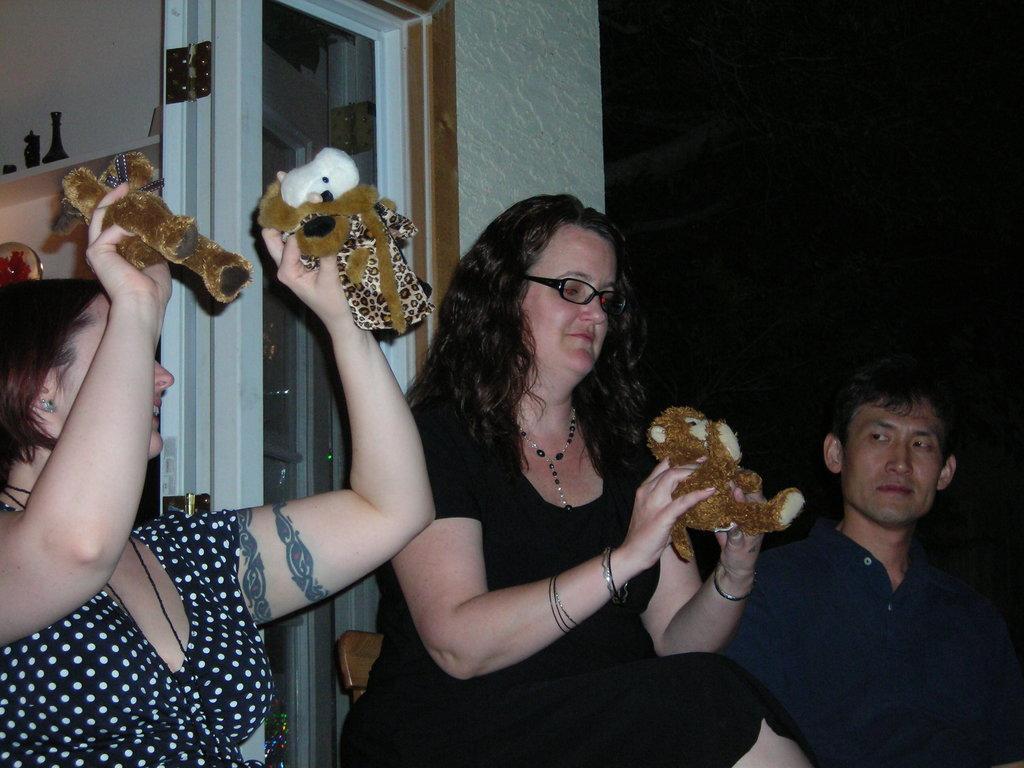Please provide a concise description of this image. In this image there are two women sitting on chair and holding a toy, beside the woman a man is sitting, in the background there is a wall and to that wall there is a door. 